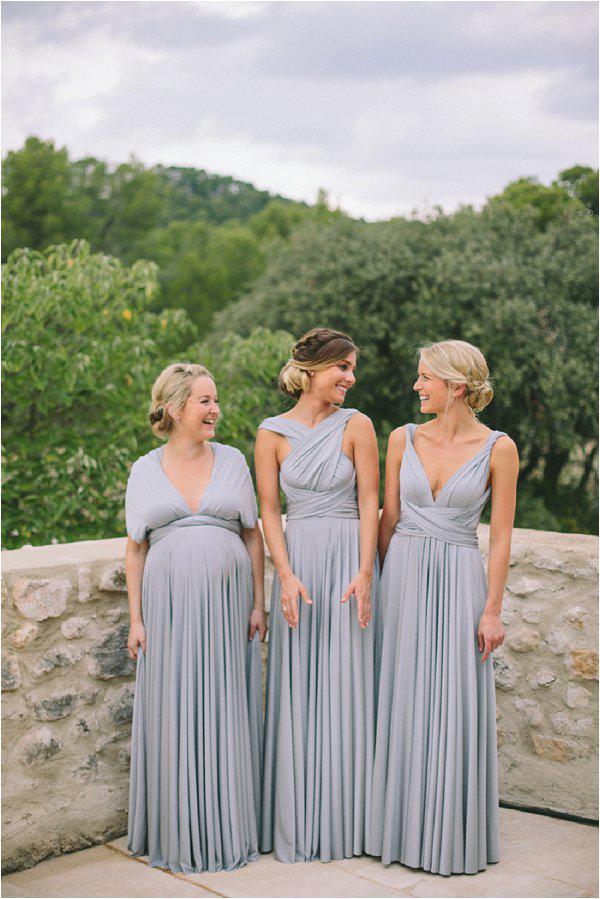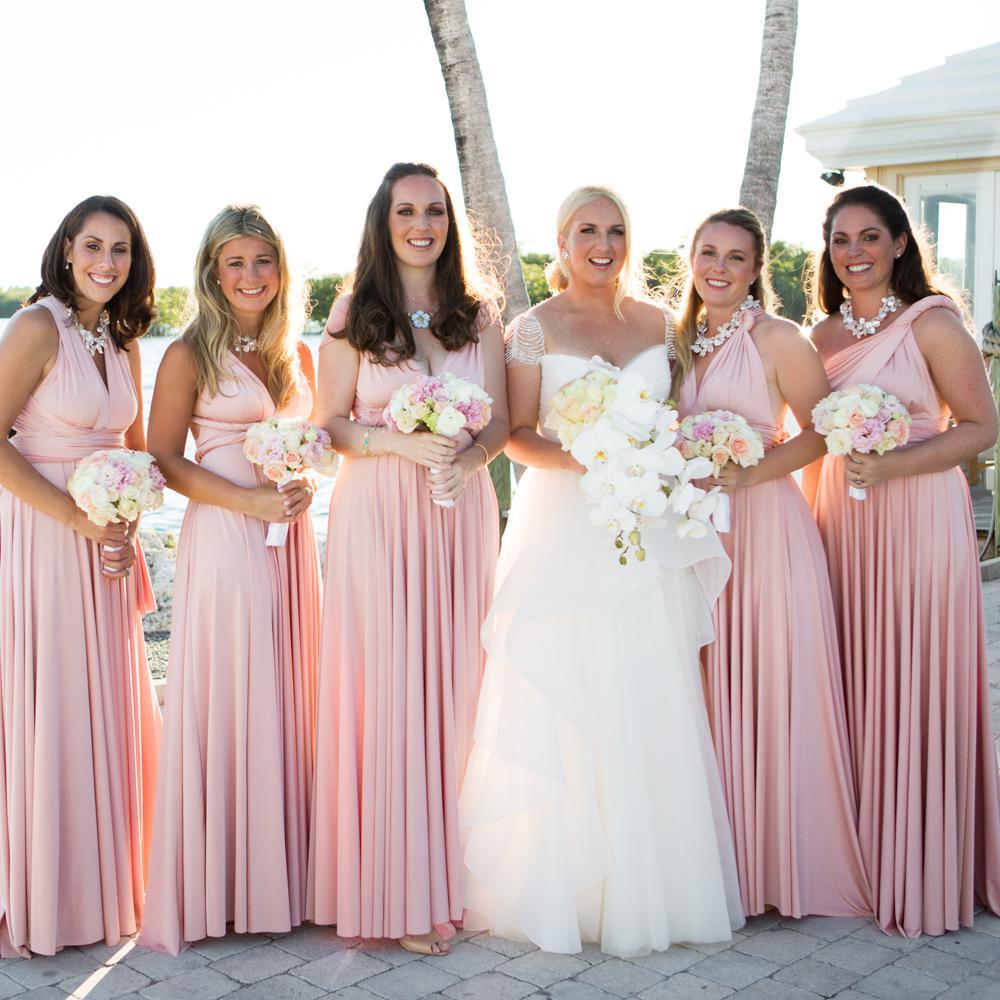The first image is the image on the left, the second image is the image on the right. Given the left and right images, does the statement "There are three women in the left image" hold true? Answer yes or no. Yes. The first image is the image on the left, the second image is the image on the right. Considering the images on both sides, is "In one image, exactly four women are shown standing in a row." valid? Answer yes or no. No. 